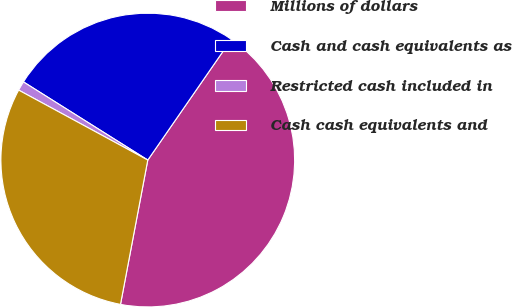Convert chart to OTSL. <chart><loc_0><loc_0><loc_500><loc_500><pie_chart><fcel>Millions of dollars<fcel>Cash and cash equivalents as<fcel>Restricted cash included in<fcel>Cash cash equivalents and<nl><fcel>43.34%<fcel>25.7%<fcel>1.03%<fcel>29.93%<nl></chart> 